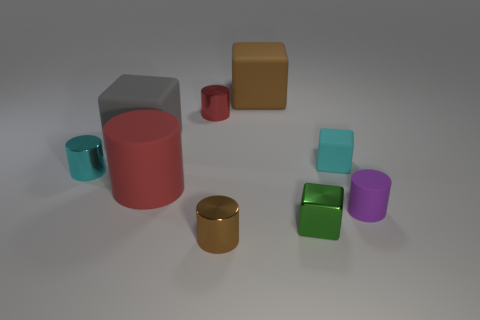Do the large matte cylinder and the tiny shiny cylinder that is behind the cyan rubber cube have the same color?
Make the answer very short. Yes. The brown object behind the small cylinder that is to the right of the cube behind the large gray rubber cube is what shape?
Give a very brief answer. Cube. What number of other things are the same color as the tiny rubber block?
Make the answer very short. 1. There is a small cyan object on the right side of the cube that is in front of the cyan metallic object; what shape is it?
Ensure brevity in your answer.  Cube. How many tiny purple rubber cylinders are on the left side of the small metal block?
Ensure brevity in your answer.  0. Is there another small thing made of the same material as the small purple object?
Offer a very short reply. Yes. There is a green block that is the same size as the cyan metal thing; what material is it?
Ensure brevity in your answer.  Metal. There is a matte object that is on the right side of the small metallic block and in front of the tiny cyan metal object; what size is it?
Provide a short and direct response. Small. The object that is left of the large brown block and behind the big gray cube is what color?
Offer a very short reply. Red. Are there fewer small objects to the left of the small brown cylinder than objects in front of the brown rubber block?
Your answer should be very brief. Yes. 